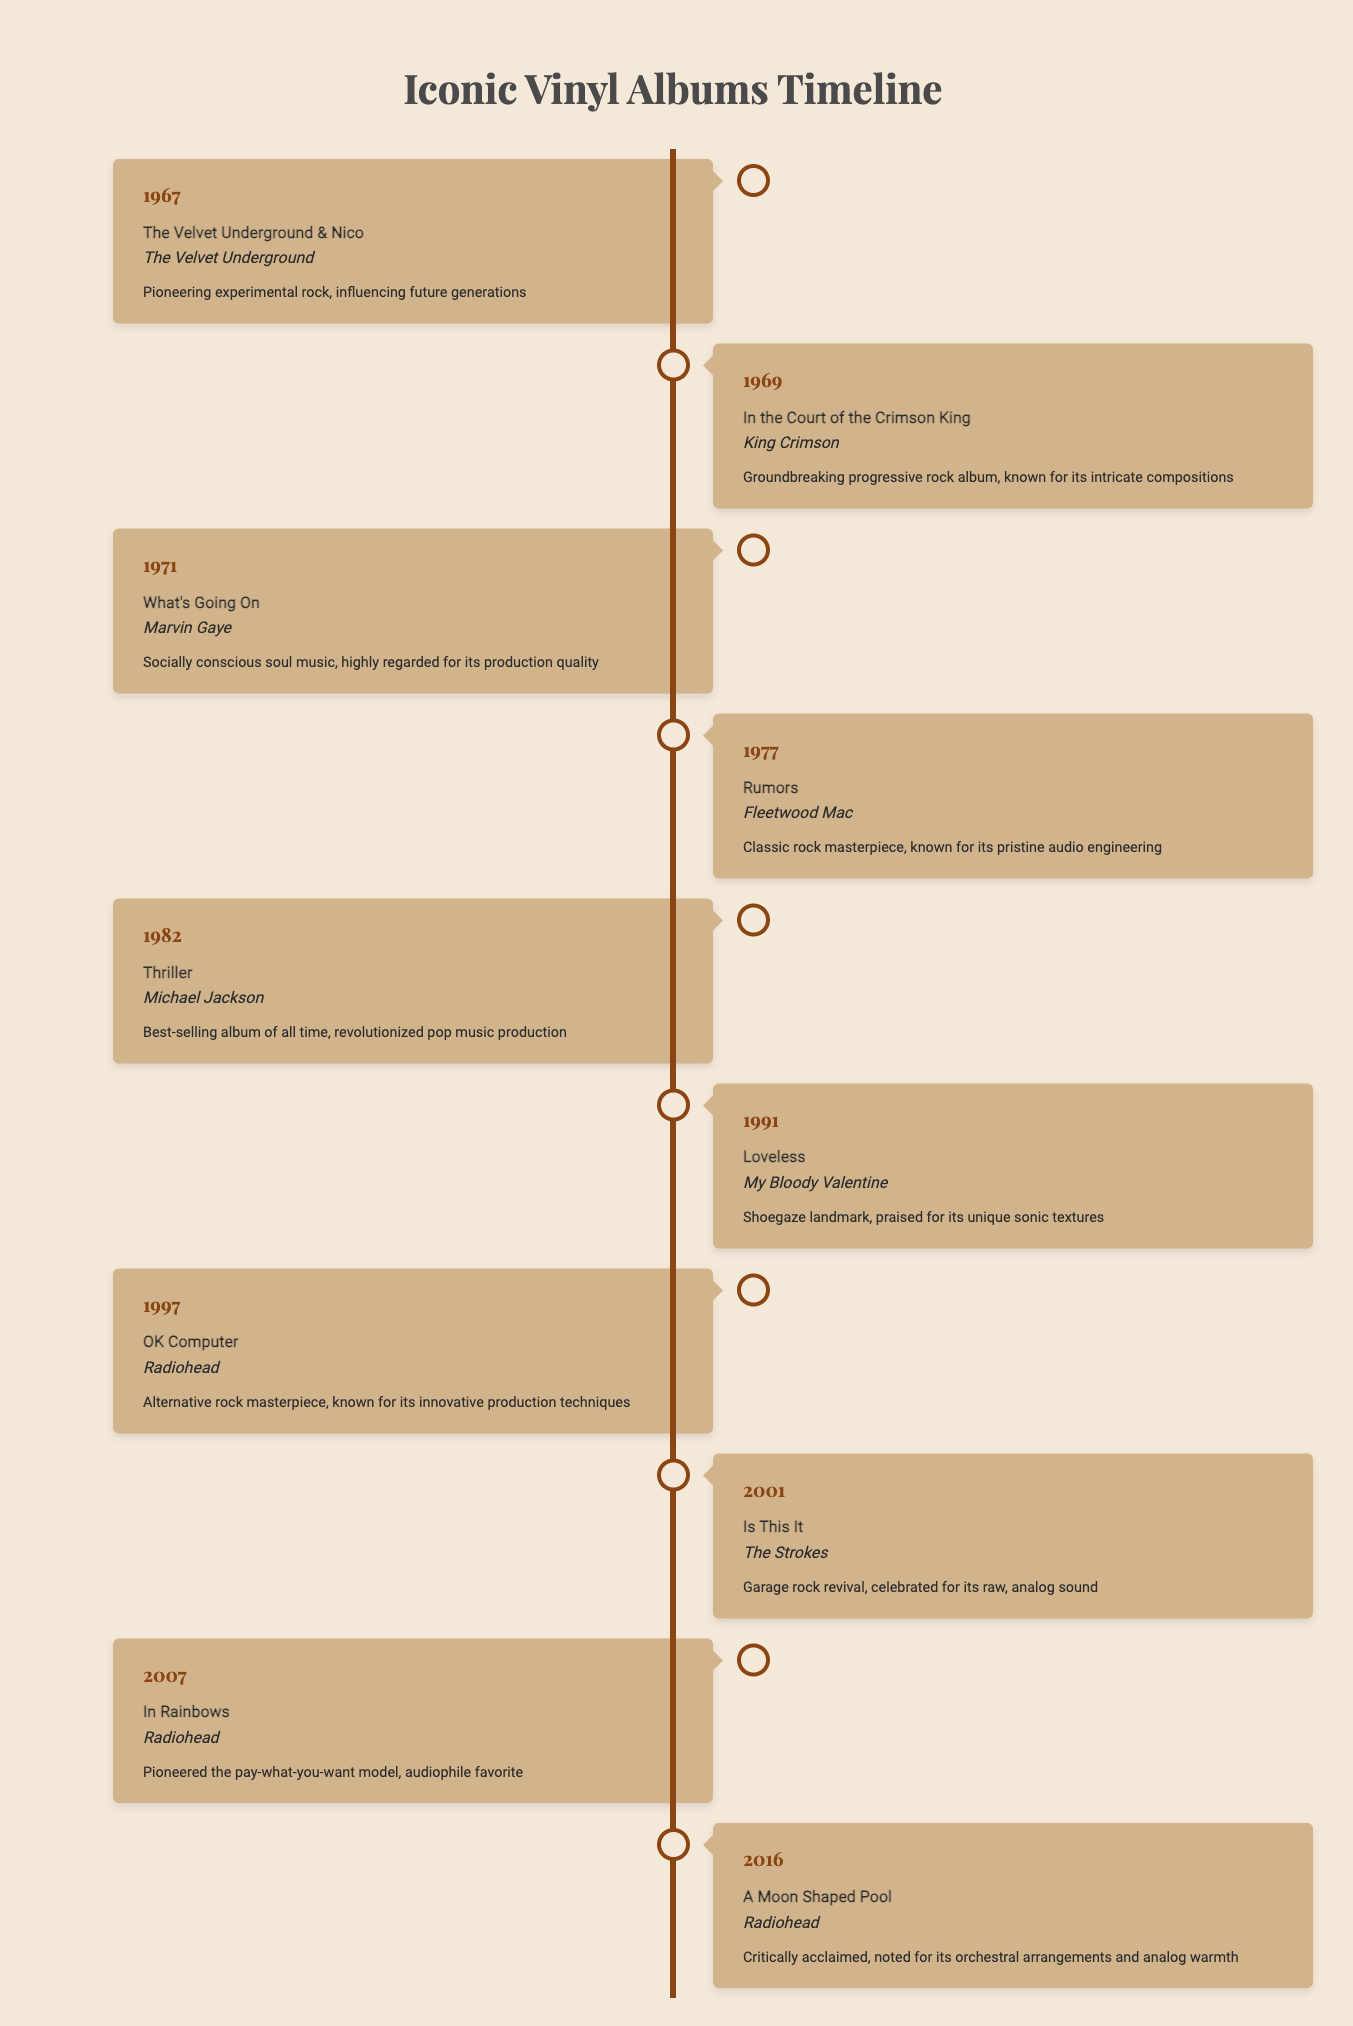What year was "The Velvet Underground & Nico" released? The table lists the release date for "The Velvet Underground & Nico" under the year 1967.
Answer: 1967 Which album by Radiohead is noted for its innovative production techniques? According to the table, "OK Computer" is the album by Radiohead known for its innovative production techniques, released in 1997.
Answer: OK Computer What is the significance of Marvin Gaye's "What's Going On"? The table specifies that "What's Going On" is highly regarded for its production quality and is considered socially conscious soul music.
Answer: Socially conscious soul music, highly regarded for its production quality How many albums were released in the 1980s? Reviewing the table, only "Thriller" by Michael Jackson from 1982 falls in the 1980s. Thus, there is 1 album released in that decade.
Answer: 1 Is "Rumors" considered a classic rock album? The table indicates that "Rumors" by Fleetwood Mac is referred to as a "classic rock masterpiece," which confirms that it is indeed a classic rock album.
Answer: Yes Which album has the earliest release date and what year was it? From the table, "The Velvet Underground & Nico" is the earliest release listed, which came out in 1967.
Answer: The Velvet Underground & Nico, 1967 Which artist has multiple albums referenced in the timeline? Upon examining the table, Radiohead appears multiple times with three albums: "OK Computer" in 1997, "In Rainbows" in 2007, and "A Moon Shaped Pool" in 2016.
Answer: Radiohead What is the average release year of the albums listed in the table? To find the average year: sum the years (1967 + 1969 + 1971 + 1977 + 1982 + 1991 + 1997 + 2001 + 2007 + 2016 = 1980) and divide by the number of albums (10). The average release year is 1980.
Answer: 1980 What genre is most represented in this timeline? Analyzing the table, various genres including rock, soul, and pop are represented. However, rock seems to dominate with several iconic albums like "Rumors," "OK Computer," and "Is This It."
Answer: Rock 